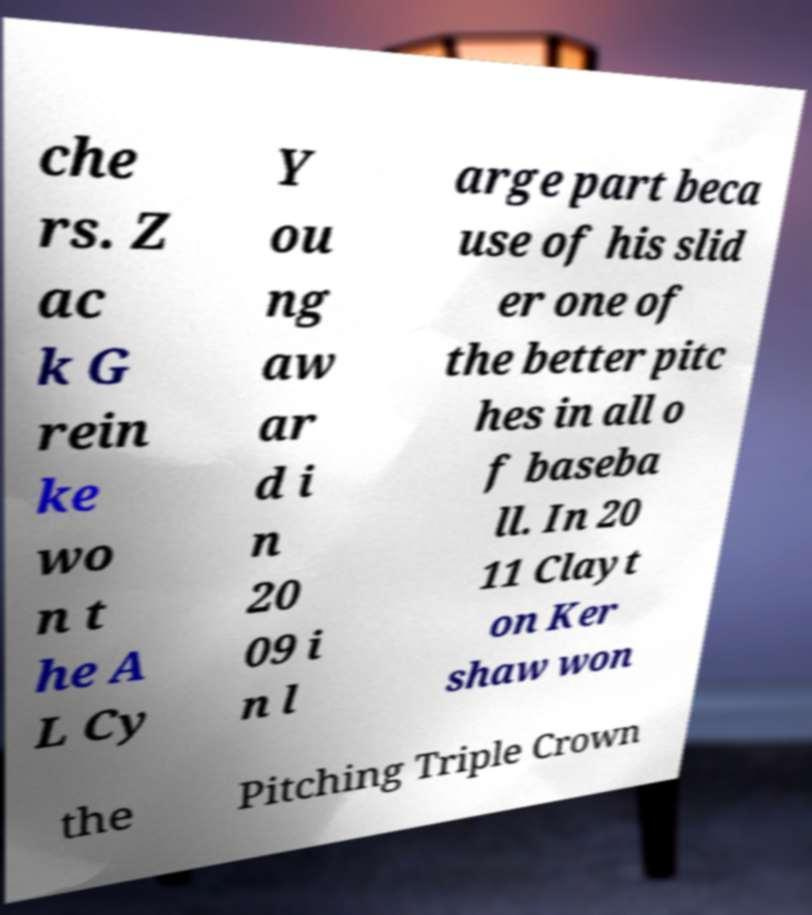Could you assist in decoding the text presented in this image and type it out clearly? che rs. Z ac k G rein ke wo n t he A L Cy Y ou ng aw ar d i n 20 09 i n l arge part beca use of his slid er one of the better pitc hes in all o f baseba ll. In 20 11 Clayt on Ker shaw won the Pitching Triple Crown 